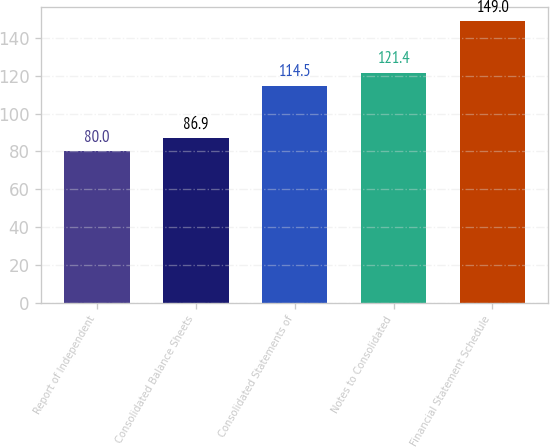Convert chart. <chart><loc_0><loc_0><loc_500><loc_500><bar_chart><fcel>Report of Independent<fcel>Consolidated Balance Sheets<fcel>Consolidated Statements of<fcel>Notes to Consolidated<fcel>Financial Statement Schedule<nl><fcel>80<fcel>86.9<fcel>114.5<fcel>121.4<fcel>149<nl></chart> 